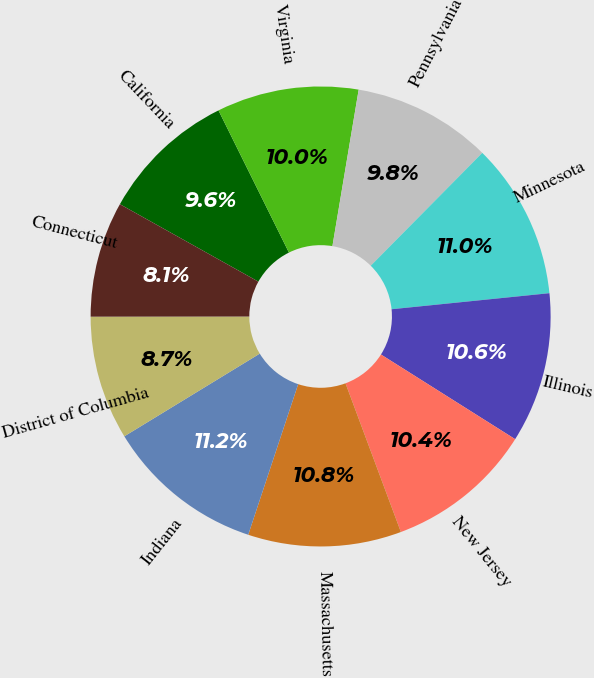<chart> <loc_0><loc_0><loc_500><loc_500><pie_chart><fcel>California<fcel>Virginia<fcel>Pennsylvania<fcel>Minnesota<fcel>Illinois<fcel>New Jersey<fcel>Massachusetts<fcel>Indiana<fcel>District of Columbia<fcel>Connecticut<nl><fcel>9.56%<fcel>9.97%<fcel>9.76%<fcel>10.98%<fcel>10.57%<fcel>10.37%<fcel>10.77%<fcel>11.18%<fcel>8.71%<fcel>8.13%<nl></chart> 